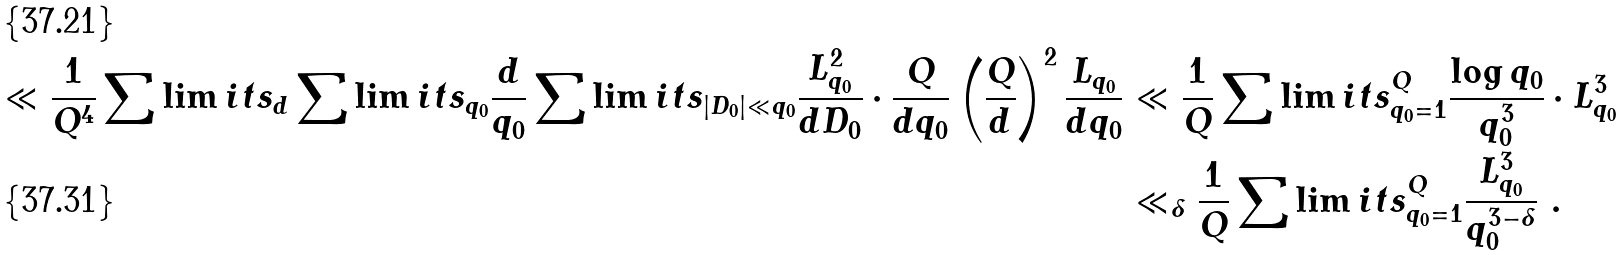<formula> <loc_0><loc_0><loc_500><loc_500>\ll \frac { 1 } { Q ^ { 4 } } \sum \lim i t s _ { d } \sum \lim i t s _ { q _ { 0 } } \frac { d } { q _ { 0 } } \sum \lim i t s _ { | D _ { 0 } | \ll q _ { 0 } } \frac { L _ { q _ { 0 } } ^ { 2 } } { d D _ { 0 } } \cdot \frac { Q } { d q _ { 0 } } \left ( \frac { Q } { d } \right ) ^ { 2 } \frac { L _ { q _ { 0 } } } { d q _ { 0 } } & \ll \frac { 1 } { Q } \sum \lim i t s _ { q _ { 0 } = 1 } ^ { Q } \frac { \log q _ { 0 } } { q _ { 0 } ^ { 3 } } \cdot L _ { q _ { 0 } } ^ { 3 } \\ & \ll _ { \delta } \frac { 1 } { Q } \sum \lim i t s _ { q _ { 0 } = 1 } ^ { Q } \frac { L _ { q _ { 0 } } ^ { 3 } } { q _ { 0 } ^ { 3 - \delta } } \ .</formula> 